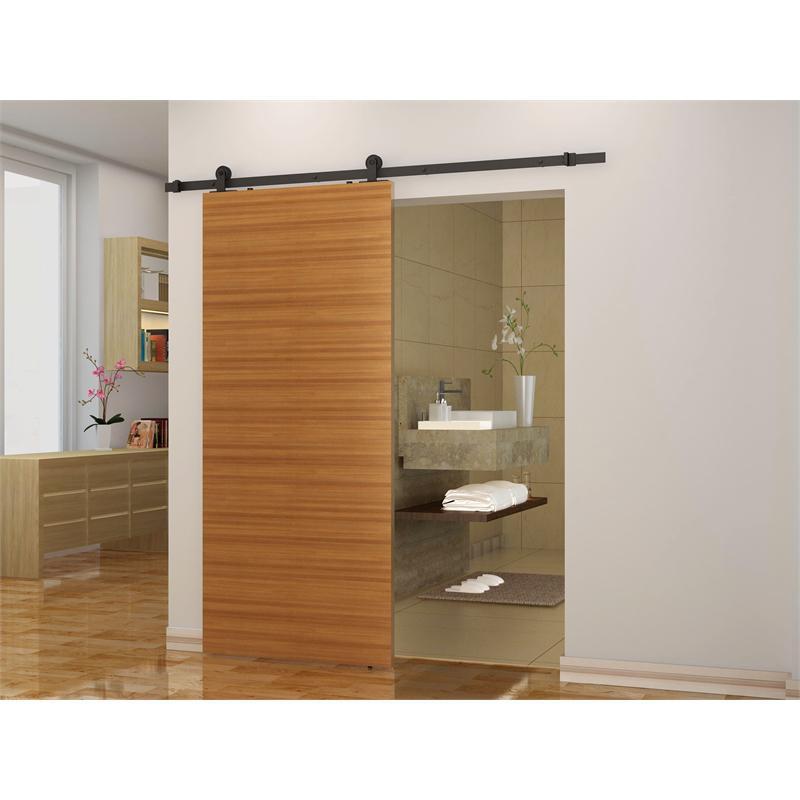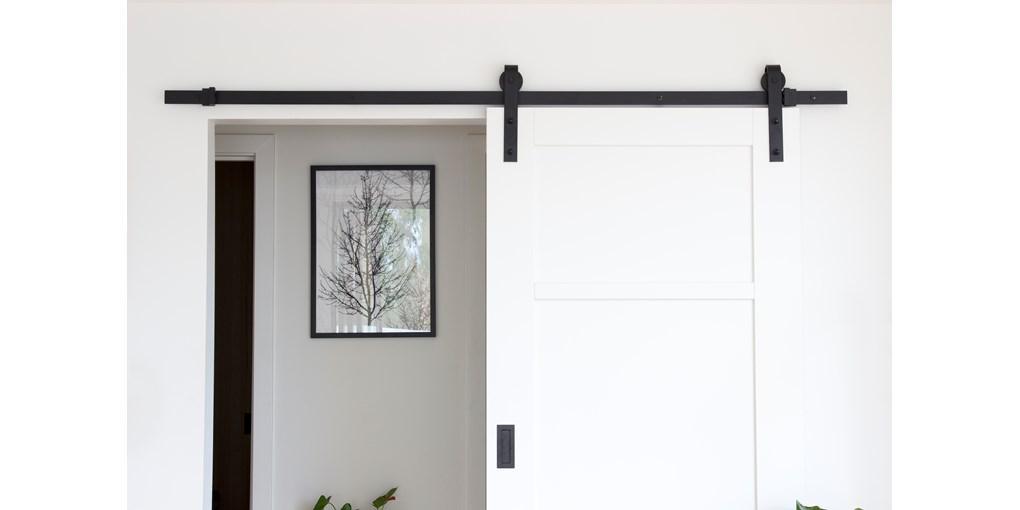The first image is the image on the left, the second image is the image on the right. Assess this claim about the two images: "There is  total of two white hanging doors.". Correct or not? Answer yes or no. No. The first image is the image on the left, the second image is the image on the right. Analyze the images presented: Is the assertion "A white door that slides on a black bar overhead has a brown rectangular 'kickplate' at the bottom of the open door." valid? Answer yes or no. No. 